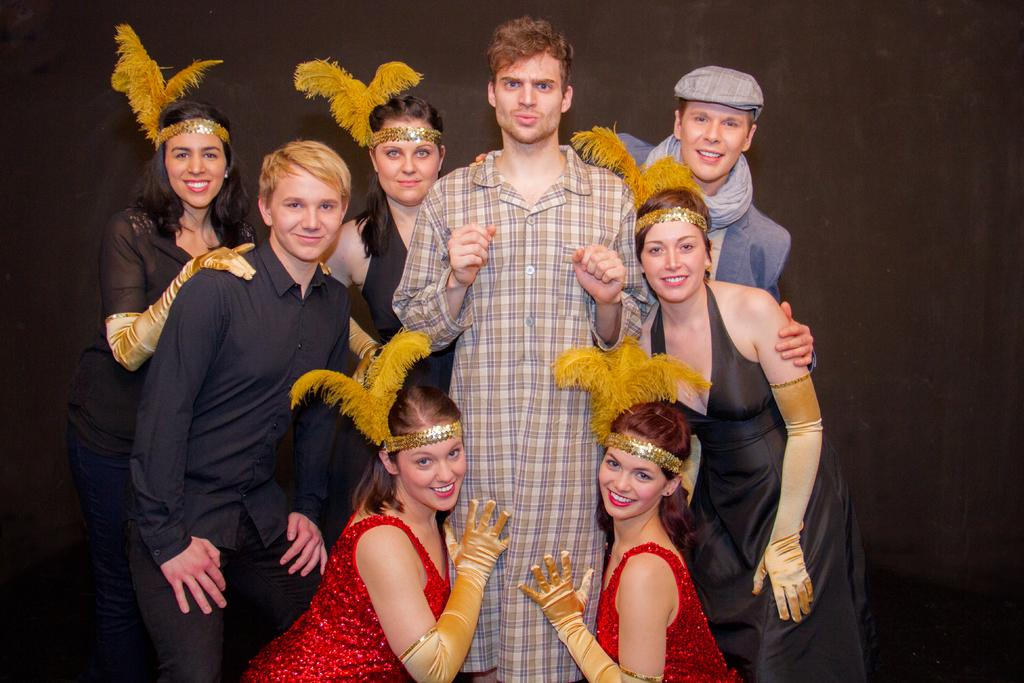How many people are in the image? There is a group of people in the image. Can you describe the clothing of one of the people? One person is wearing a red dress. What about another person's clothing? Another person is wearing a brown and gray shirt. What is the color of the background in the image? The background of the image is dark. What type of discussion is taking place among the mice in the image? There are no mice present in the image, so there cannot be a discussion among them. 